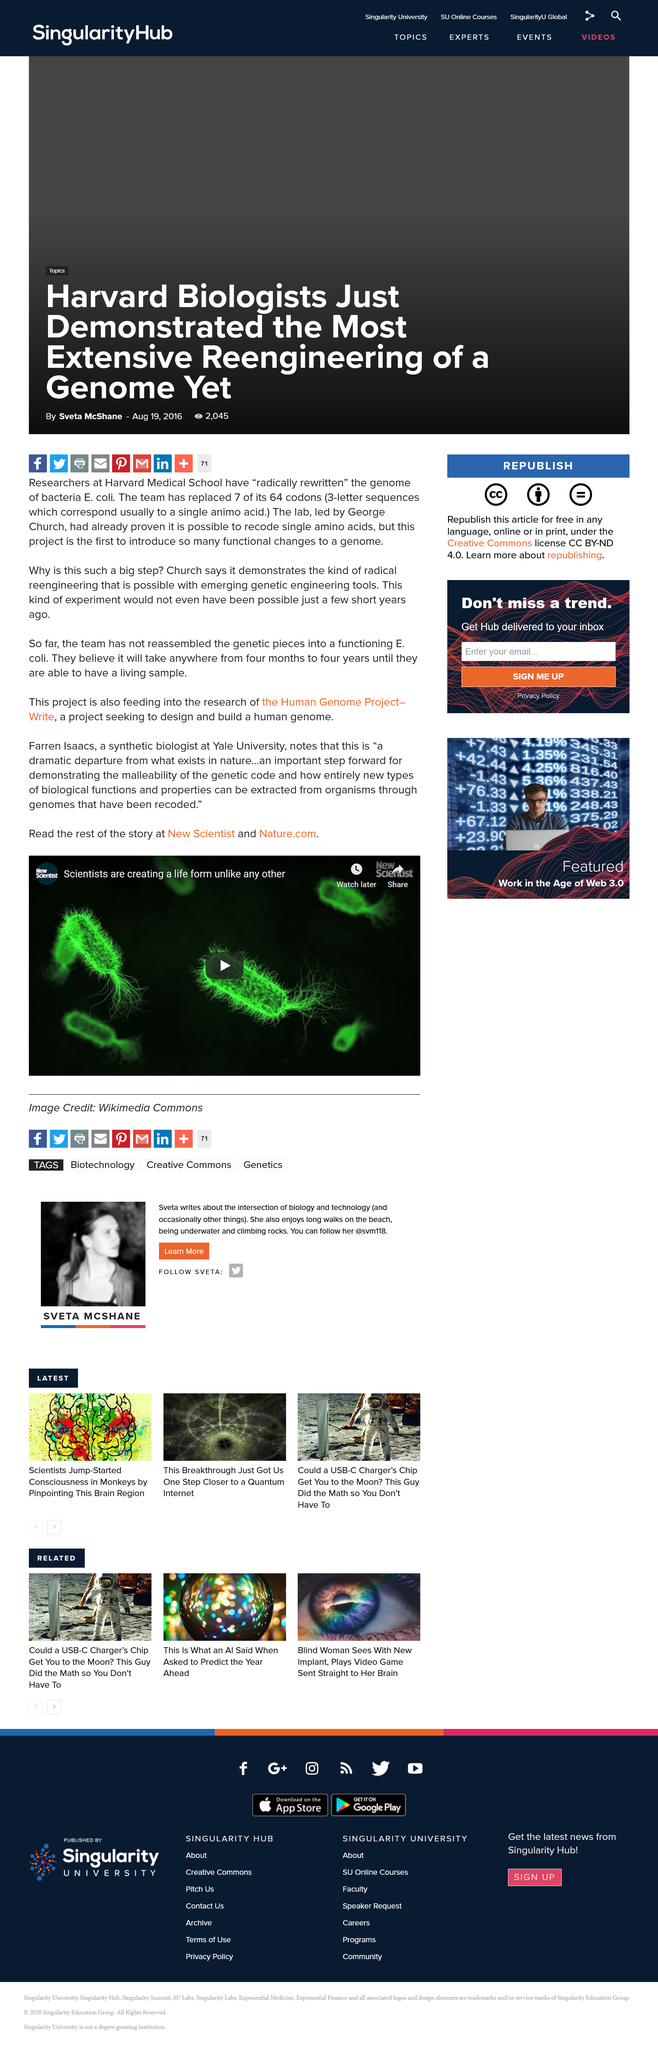Point out several critical features in this image. Farren Isaacs is a synthetic biologist who works at Yale University. This project seeks to design and build a human genome, with the goal of creating a reliable and efficient means of analyzing DNA. The rest of the story can be read in New Scientist and Nature.com. 